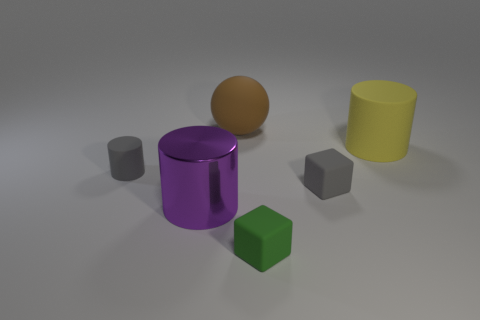There is a tiny cylinder; is its color the same as the rubber block that is behind the big purple metallic object? yes 